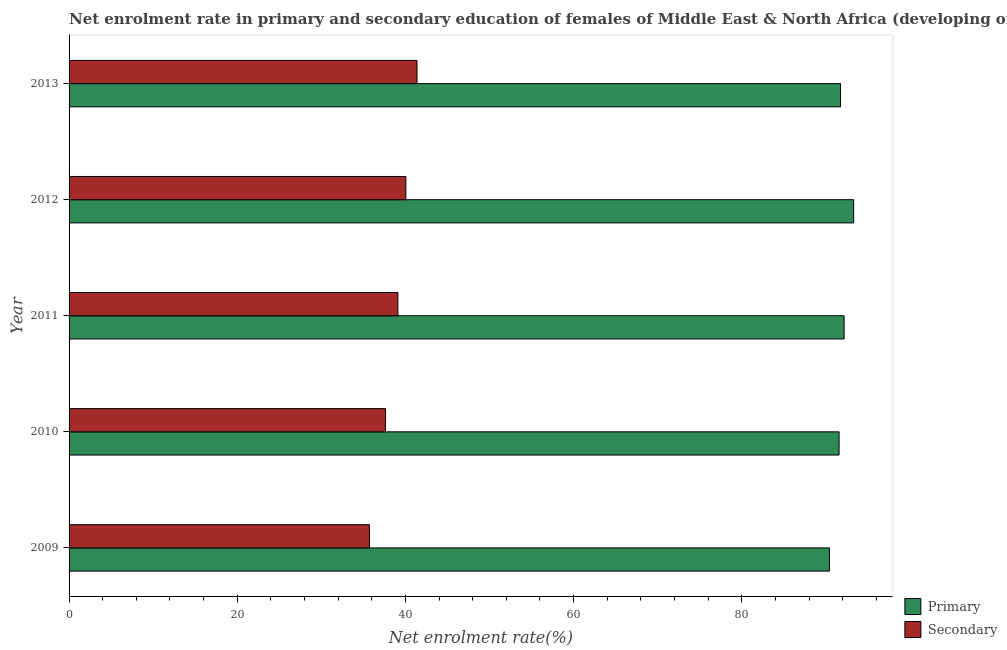Are the number of bars on each tick of the Y-axis equal?
Ensure brevity in your answer.  Yes. How many bars are there on the 2nd tick from the top?
Your answer should be compact. 2. How many bars are there on the 4th tick from the bottom?
Provide a short and direct response. 2. What is the enrollment rate in secondary education in 2010?
Your answer should be very brief. 37.63. Across all years, what is the maximum enrollment rate in secondary education?
Offer a terse response. 41.38. Across all years, what is the minimum enrollment rate in primary education?
Give a very brief answer. 90.42. In which year was the enrollment rate in secondary education maximum?
Keep it short and to the point. 2013. In which year was the enrollment rate in primary education minimum?
Keep it short and to the point. 2009. What is the total enrollment rate in secondary education in the graph?
Provide a short and direct response. 193.89. What is the difference between the enrollment rate in primary education in 2009 and that in 2011?
Keep it short and to the point. -1.75. What is the difference between the enrollment rate in primary education in 2011 and the enrollment rate in secondary education in 2013?
Your response must be concise. 50.79. What is the average enrollment rate in primary education per year?
Offer a terse response. 91.84. In the year 2009, what is the difference between the enrollment rate in secondary education and enrollment rate in primary education?
Your response must be concise. -54.7. In how many years, is the enrollment rate in primary education greater than 24 %?
Make the answer very short. 5. Is the enrollment rate in primary education in 2009 less than that in 2012?
Your answer should be very brief. Yes. What is the difference between the highest and the second highest enrollment rate in secondary education?
Your response must be concise. 1.33. What is the difference between the highest and the lowest enrollment rate in primary education?
Offer a terse response. 2.88. In how many years, is the enrollment rate in secondary education greater than the average enrollment rate in secondary education taken over all years?
Offer a very short reply. 3. What does the 1st bar from the top in 2010 represents?
Provide a succinct answer. Secondary. What does the 2nd bar from the bottom in 2013 represents?
Your response must be concise. Secondary. How many bars are there?
Provide a succinct answer. 10. Are all the bars in the graph horizontal?
Ensure brevity in your answer.  Yes. Are the values on the major ticks of X-axis written in scientific E-notation?
Your answer should be very brief. No. Does the graph contain any zero values?
Your answer should be compact. No. Where does the legend appear in the graph?
Offer a terse response. Bottom right. How many legend labels are there?
Provide a short and direct response. 2. What is the title of the graph?
Make the answer very short. Net enrolment rate in primary and secondary education of females of Middle East & North Africa (developing only). Does "constant 2005 US$" appear as one of the legend labels in the graph?
Offer a very short reply. No. What is the label or title of the X-axis?
Offer a very short reply. Net enrolment rate(%). What is the label or title of the Y-axis?
Ensure brevity in your answer.  Year. What is the Net enrolment rate(%) of Primary in 2009?
Ensure brevity in your answer.  90.42. What is the Net enrolment rate(%) of Secondary in 2009?
Provide a succinct answer. 35.72. What is the Net enrolment rate(%) in Primary in 2010?
Your answer should be compact. 91.57. What is the Net enrolment rate(%) in Secondary in 2010?
Your answer should be compact. 37.63. What is the Net enrolment rate(%) of Primary in 2011?
Make the answer very short. 92.17. What is the Net enrolment rate(%) of Secondary in 2011?
Offer a terse response. 39.1. What is the Net enrolment rate(%) of Primary in 2012?
Your answer should be compact. 93.3. What is the Net enrolment rate(%) in Secondary in 2012?
Make the answer very short. 40.05. What is the Net enrolment rate(%) of Primary in 2013?
Give a very brief answer. 91.74. What is the Net enrolment rate(%) in Secondary in 2013?
Provide a short and direct response. 41.38. Across all years, what is the maximum Net enrolment rate(%) in Primary?
Provide a succinct answer. 93.3. Across all years, what is the maximum Net enrolment rate(%) of Secondary?
Make the answer very short. 41.38. Across all years, what is the minimum Net enrolment rate(%) in Primary?
Make the answer very short. 90.42. Across all years, what is the minimum Net enrolment rate(%) of Secondary?
Your answer should be compact. 35.72. What is the total Net enrolment rate(%) of Primary in the graph?
Provide a short and direct response. 459.21. What is the total Net enrolment rate(%) of Secondary in the graph?
Ensure brevity in your answer.  193.89. What is the difference between the Net enrolment rate(%) in Primary in 2009 and that in 2010?
Your response must be concise. -1.15. What is the difference between the Net enrolment rate(%) of Secondary in 2009 and that in 2010?
Your answer should be compact. -1.91. What is the difference between the Net enrolment rate(%) in Primary in 2009 and that in 2011?
Give a very brief answer. -1.75. What is the difference between the Net enrolment rate(%) of Secondary in 2009 and that in 2011?
Your answer should be very brief. -3.38. What is the difference between the Net enrolment rate(%) of Primary in 2009 and that in 2012?
Provide a short and direct response. -2.88. What is the difference between the Net enrolment rate(%) in Secondary in 2009 and that in 2012?
Keep it short and to the point. -4.33. What is the difference between the Net enrolment rate(%) of Primary in 2009 and that in 2013?
Offer a terse response. -1.32. What is the difference between the Net enrolment rate(%) in Secondary in 2009 and that in 2013?
Your response must be concise. -5.66. What is the difference between the Net enrolment rate(%) in Primary in 2010 and that in 2011?
Ensure brevity in your answer.  -0.6. What is the difference between the Net enrolment rate(%) in Secondary in 2010 and that in 2011?
Your response must be concise. -1.47. What is the difference between the Net enrolment rate(%) of Primary in 2010 and that in 2012?
Your answer should be very brief. -1.73. What is the difference between the Net enrolment rate(%) in Secondary in 2010 and that in 2012?
Your answer should be very brief. -2.42. What is the difference between the Net enrolment rate(%) in Primary in 2010 and that in 2013?
Give a very brief answer. -0.17. What is the difference between the Net enrolment rate(%) in Secondary in 2010 and that in 2013?
Your response must be concise. -3.74. What is the difference between the Net enrolment rate(%) of Primary in 2011 and that in 2012?
Your answer should be compact. -1.13. What is the difference between the Net enrolment rate(%) in Secondary in 2011 and that in 2012?
Make the answer very short. -0.95. What is the difference between the Net enrolment rate(%) in Primary in 2011 and that in 2013?
Keep it short and to the point. 0.43. What is the difference between the Net enrolment rate(%) of Secondary in 2011 and that in 2013?
Offer a terse response. -2.27. What is the difference between the Net enrolment rate(%) of Primary in 2012 and that in 2013?
Your response must be concise. 1.56. What is the difference between the Net enrolment rate(%) of Secondary in 2012 and that in 2013?
Your answer should be compact. -1.33. What is the difference between the Net enrolment rate(%) of Primary in 2009 and the Net enrolment rate(%) of Secondary in 2010?
Offer a very short reply. 52.79. What is the difference between the Net enrolment rate(%) of Primary in 2009 and the Net enrolment rate(%) of Secondary in 2011?
Make the answer very short. 51.32. What is the difference between the Net enrolment rate(%) in Primary in 2009 and the Net enrolment rate(%) in Secondary in 2012?
Ensure brevity in your answer.  50.37. What is the difference between the Net enrolment rate(%) in Primary in 2009 and the Net enrolment rate(%) in Secondary in 2013?
Make the answer very short. 49.05. What is the difference between the Net enrolment rate(%) of Primary in 2010 and the Net enrolment rate(%) of Secondary in 2011?
Provide a succinct answer. 52.47. What is the difference between the Net enrolment rate(%) in Primary in 2010 and the Net enrolment rate(%) in Secondary in 2012?
Keep it short and to the point. 51.52. What is the difference between the Net enrolment rate(%) in Primary in 2010 and the Net enrolment rate(%) in Secondary in 2013?
Provide a succinct answer. 50.19. What is the difference between the Net enrolment rate(%) in Primary in 2011 and the Net enrolment rate(%) in Secondary in 2012?
Your answer should be compact. 52.12. What is the difference between the Net enrolment rate(%) in Primary in 2011 and the Net enrolment rate(%) in Secondary in 2013?
Offer a terse response. 50.79. What is the difference between the Net enrolment rate(%) of Primary in 2012 and the Net enrolment rate(%) of Secondary in 2013?
Your response must be concise. 51.92. What is the average Net enrolment rate(%) of Primary per year?
Provide a short and direct response. 91.84. What is the average Net enrolment rate(%) in Secondary per year?
Provide a short and direct response. 38.78. In the year 2009, what is the difference between the Net enrolment rate(%) in Primary and Net enrolment rate(%) in Secondary?
Make the answer very short. 54.7. In the year 2010, what is the difference between the Net enrolment rate(%) in Primary and Net enrolment rate(%) in Secondary?
Make the answer very short. 53.94. In the year 2011, what is the difference between the Net enrolment rate(%) in Primary and Net enrolment rate(%) in Secondary?
Your answer should be compact. 53.07. In the year 2012, what is the difference between the Net enrolment rate(%) in Primary and Net enrolment rate(%) in Secondary?
Your answer should be compact. 53.25. In the year 2013, what is the difference between the Net enrolment rate(%) in Primary and Net enrolment rate(%) in Secondary?
Your answer should be compact. 50.36. What is the ratio of the Net enrolment rate(%) of Primary in 2009 to that in 2010?
Offer a terse response. 0.99. What is the ratio of the Net enrolment rate(%) in Secondary in 2009 to that in 2010?
Provide a succinct answer. 0.95. What is the ratio of the Net enrolment rate(%) in Primary in 2009 to that in 2011?
Provide a short and direct response. 0.98. What is the ratio of the Net enrolment rate(%) of Secondary in 2009 to that in 2011?
Your answer should be compact. 0.91. What is the ratio of the Net enrolment rate(%) in Primary in 2009 to that in 2012?
Your response must be concise. 0.97. What is the ratio of the Net enrolment rate(%) of Secondary in 2009 to that in 2012?
Give a very brief answer. 0.89. What is the ratio of the Net enrolment rate(%) in Primary in 2009 to that in 2013?
Keep it short and to the point. 0.99. What is the ratio of the Net enrolment rate(%) in Secondary in 2009 to that in 2013?
Ensure brevity in your answer.  0.86. What is the ratio of the Net enrolment rate(%) in Secondary in 2010 to that in 2011?
Give a very brief answer. 0.96. What is the ratio of the Net enrolment rate(%) in Primary in 2010 to that in 2012?
Make the answer very short. 0.98. What is the ratio of the Net enrolment rate(%) in Secondary in 2010 to that in 2012?
Ensure brevity in your answer.  0.94. What is the ratio of the Net enrolment rate(%) of Secondary in 2010 to that in 2013?
Offer a very short reply. 0.91. What is the ratio of the Net enrolment rate(%) of Primary in 2011 to that in 2012?
Your answer should be compact. 0.99. What is the ratio of the Net enrolment rate(%) in Secondary in 2011 to that in 2012?
Offer a terse response. 0.98. What is the ratio of the Net enrolment rate(%) in Primary in 2011 to that in 2013?
Offer a terse response. 1. What is the ratio of the Net enrolment rate(%) of Secondary in 2011 to that in 2013?
Give a very brief answer. 0.94. What is the ratio of the Net enrolment rate(%) in Primary in 2012 to that in 2013?
Give a very brief answer. 1.02. What is the ratio of the Net enrolment rate(%) in Secondary in 2012 to that in 2013?
Your answer should be compact. 0.97. What is the difference between the highest and the second highest Net enrolment rate(%) in Primary?
Provide a succinct answer. 1.13. What is the difference between the highest and the second highest Net enrolment rate(%) in Secondary?
Offer a terse response. 1.33. What is the difference between the highest and the lowest Net enrolment rate(%) in Primary?
Ensure brevity in your answer.  2.88. What is the difference between the highest and the lowest Net enrolment rate(%) of Secondary?
Your answer should be compact. 5.66. 